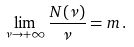<formula> <loc_0><loc_0><loc_500><loc_500>\lim _ { \nu \to + \infty } { \frac { N ( \nu ) } { \nu } } = m \, .</formula> 